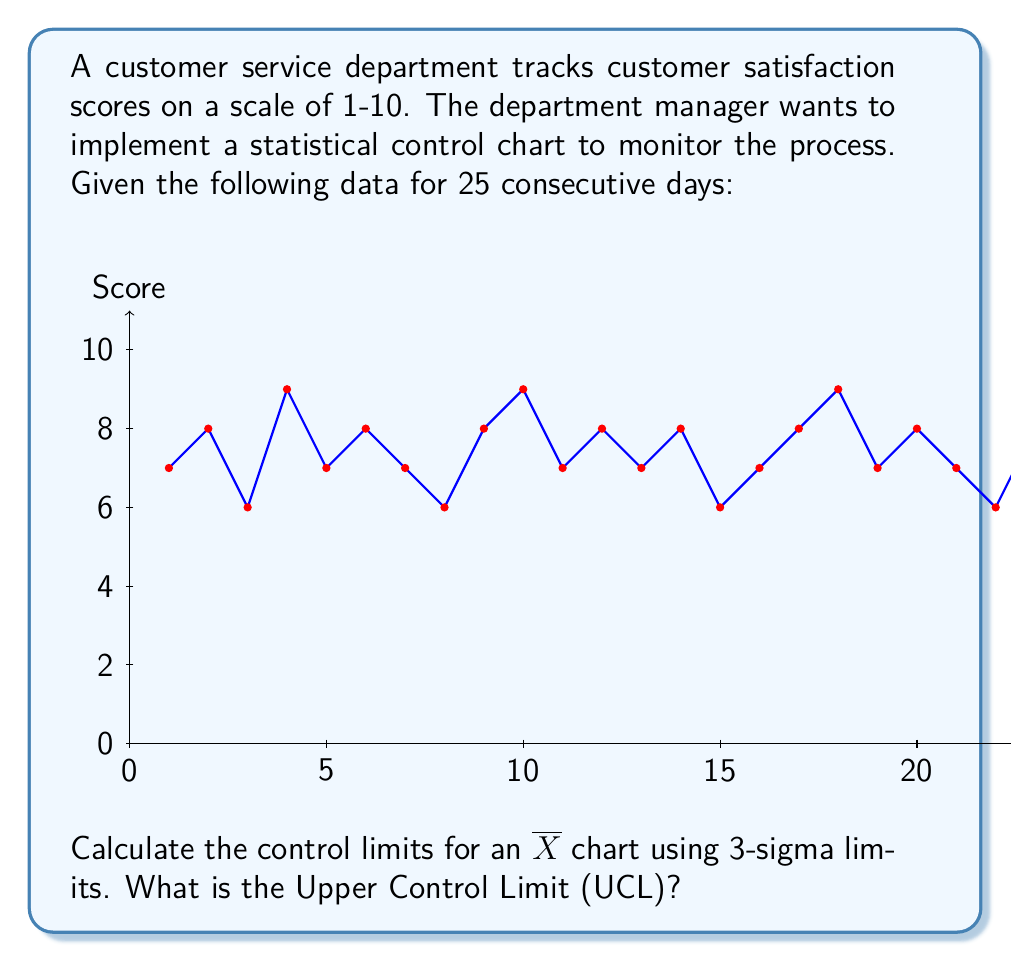Help me with this question. To calculate the control limits for an $\overline{X}$ chart, we need to follow these steps:

1. Calculate the mean ($\overline{\overline{X}}$) of all data points:
   $$\overline{\overline{X}} = \frac{\sum_{i=1}^{25} X_i}{25} = \frac{189}{25} = 7.56$$

2. Calculate the standard deviation ($s$) of the data:
   $$s = \sqrt{\frac{\sum_{i=1}^{25} (X_i - \overline{\overline{X}})^2}{24}} \approx 0.9165$$

3. Calculate the standard error of the mean ($SE_{\overline{X}}$):
   $$SE_{\overline{X}} = \frac{s}{\sqrt{n}} = \frac{0.9165}{\sqrt{25}} \approx 0.1833$$

4. Calculate the Upper Control Limit (UCL) using the 3-sigma rule:
   $$UCL = \overline{\overline{X}} + 3 \times SE_{\overline{X}}$$
   $$UCL = 7.56 + 3 \times 0.1833 \approx 8.11$$

Therefore, the Upper Control Limit (UCL) for the $\overline{X}$ chart is approximately 8.11.
Answer: 8.11 